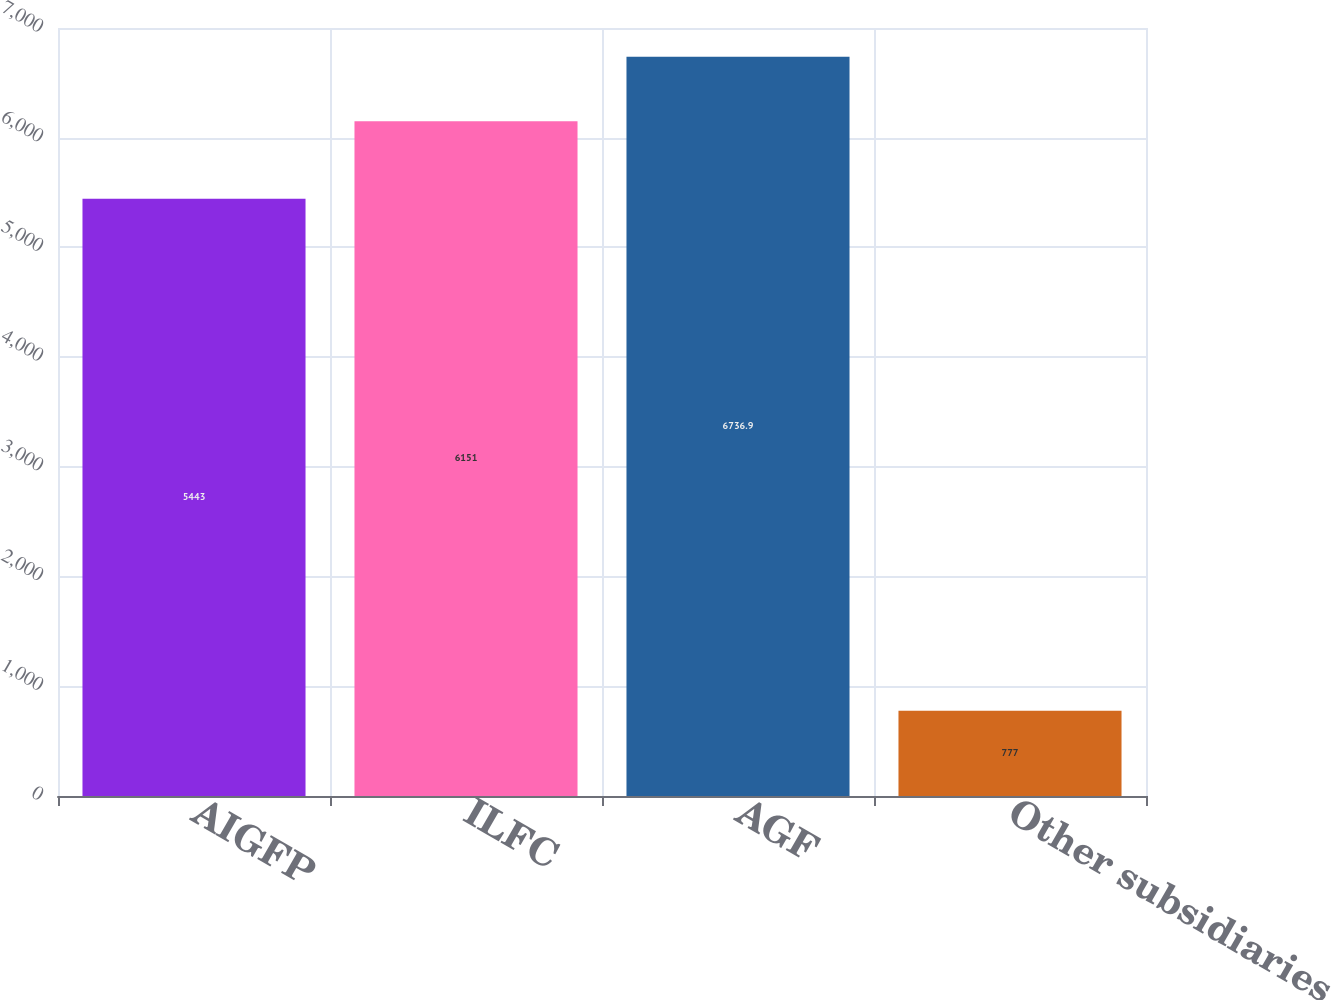Convert chart. <chart><loc_0><loc_0><loc_500><loc_500><bar_chart><fcel>AIGFP<fcel>ILFC<fcel>AGF<fcel>Other subsidiaries<nl><fcel>5443<fcel>6151<fcel>6736.9<fcel>777<nl></chart> 